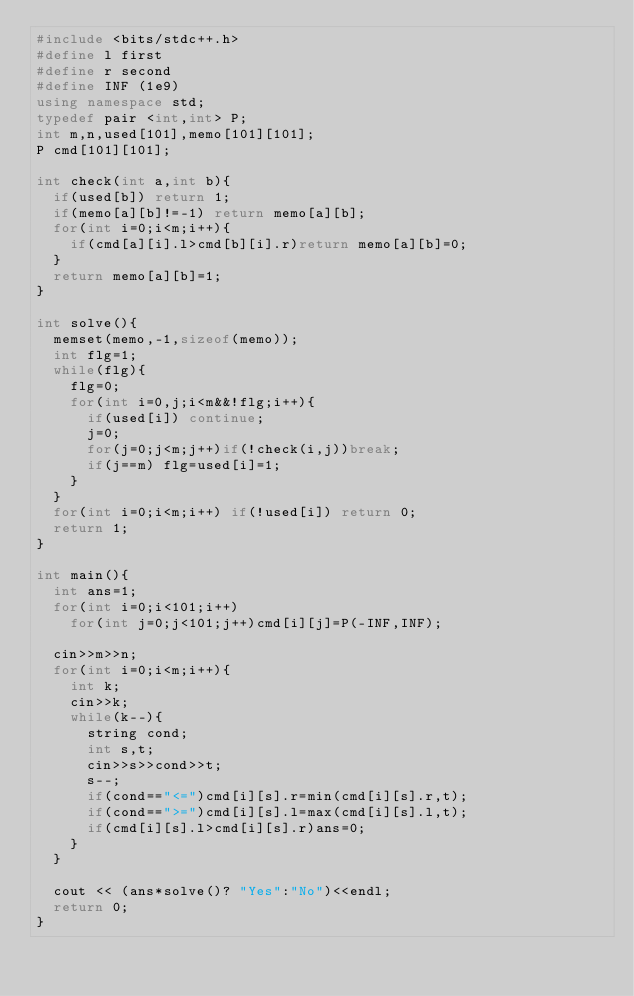<code> <loc_0><loc_0><loc_500><loc_500><_C++_>#include <bits/stdc++.h>
#define l first
#define r second
#define INF (1e9)
using namespace std;
typedef pair <int,int> P;
int m,n,used[101],memo[101][101];
P cmd[101][101];

int check(int a,int b){
  if(used[b]) return 1;
  if(memo[a][b]!=-1) return memo[a][b];
  for(int i=0;i<m;i++){
    if(cmd[a][i].l>cmd[b][i].r)return memo[a][b]=0;
  }
  return memo[a][b]=1;
}

int solve(){
  memset(memo,-1,sizeof(memo));
  int flg=1;
  while(flg){
    flg=0;
    for(int i=0,j;i<m&&!flg;i++){
      if(used[i]) continue;
      j=0;
      for(j=0;j<m;j++)if(!check(i,j))break;
      if(j==m) flg=used[i]=1;
    }
  }
  for(int i=0;i<m;i++) if(!used[i]) return 0;
  return 1;
}

int main(){
  int ans=1;
  for(int i=0;i<101;i++)
    for(int j=0;j<101;j++)cmd[i][j]=P(-INF,INF);

  cin>>m>>n;
  for(int i=0;i<m;i++){
    int k;
    cin>>k;
    while(k--){
      string cond;
      int s,t;
      cin>>s>>cond>>t;
      s--;
      if(cond=="<=")cmd[i][s].r=min(cmd[i][s].r,t);
      if(cond==">=")cmd[i][s].l=max(cmd[i][s].l,t);
      if(cmd[i][s].l>cmd[i][s].r)ans=0;
    }
  }

  cout << (ans*solve()? "Yes":"No")<<endl;
  return 0;
}</code> 